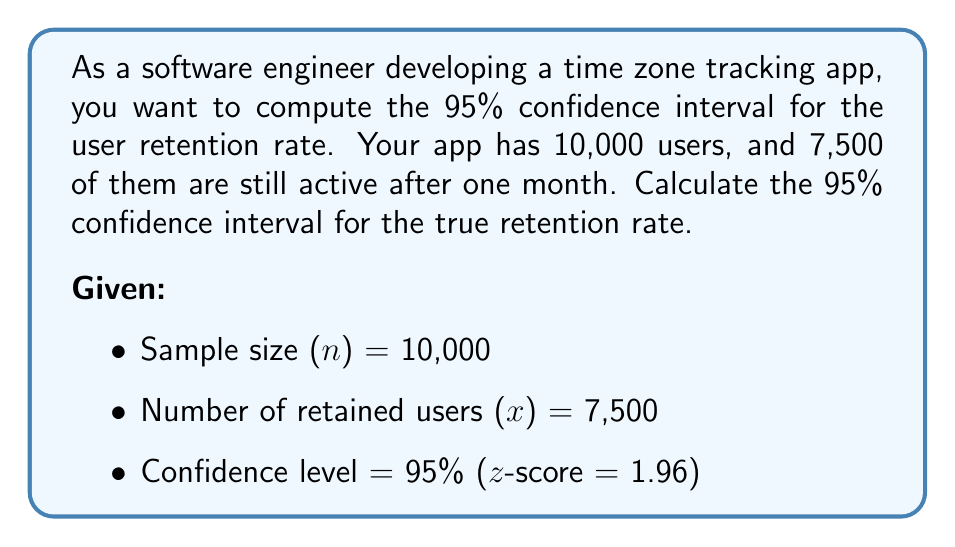Show me your answer to this math problem. To calculate the confidence interval for a proportion, we'll use the formula:

$$ p \pm z \sqrt{\frac{p(1-p)}{n}} $$

Where:
- $p$ is the sample proportion
- $z$ is the z-score for the desired confidence level
- $n$ is the sample size

Step 1: Calculate the sample proportion (p)
$$ p = \frac{x}{n} = \frac{7,500}{10,000} = 0.75 $$

Step 2: Calculate the standard error (SE)
$$ SE = \sqrt{\frac{p(1-p)}{n}} = \sqrt{\frac{0.75(1-0.75)}{10,000}} = \sqrt{\frac{0.1875}{10,000}} = 0.00433 $$

Step 3: Calculate the margin of error (ME)
$$ ME = z \times SE = 1.96 \times 0.00433 = 0.00848 $$

Step 4: Calculate the confidence interval
Lower bound: $0.75 - 0.00848 = 0.74152$
Upper bound: $0.75 + 0.00848 = 0.75848$

Therefore, the 95% confidence interval for the true retention rate is (0.74152, 0.75848) or (74.15%, 75.85%).
Answer: (0.74152, 0.75848) 